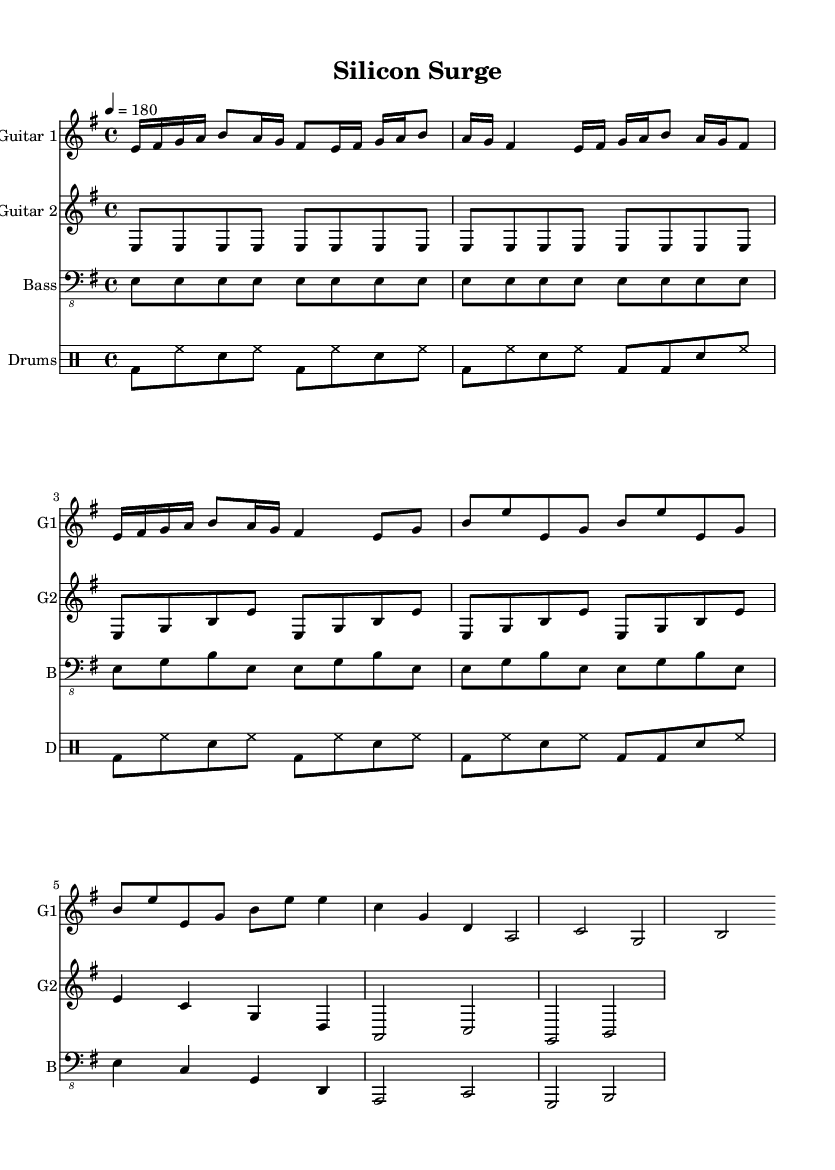What is the key signature of this music? The key signature shown in the music is E minor, which has one sharp (F#). This can be determined by looking at the key signature indicated at the beginning of the staff lines.
Answer: E minor What is the time signature of this music? The time signature is 4/4, which indicates four beats in each measure and a quarter note receives one beat. This can be seen at the beginning of the musical notation.
Answer: 4/4 What is the tempo marking for this piece? The tempo marking is 180 beats per minute. It is indicated at the beginning of the score after the time signature, specifying the speed of the piece.
Answer: 180 How many measures are in the main riff? The main riff consists of 4 measures as it repeats the initial 2-measure riff twice. This can be calculated by counting the measures dedicated to that section of the music.
Answer: 4 What is the structure of the song based on the sections provided? The structure follows a pattern of Main Riff, Verse, Chorus, and Bridge, which is a typical arrangement found in thrash metal songs. Analyzing the different sections helps to understand this organization.
Answer: Main Riff, Verse, Chorus, Bridge What type of guitar is used for the first staff? The first staff indicates "Guitar 1" as the instrument name. This is shown explicitly in the header of that staff section, denoting the specific instrument being scored.
Answer: Guitar 1 What is the primary role of the bass in this piece? The bass primarily provides the foundational rhythm and reinforces the harmony within the song, which can be inferred from its corresponding notes and rhythmic patterns that align with the other instruments.
Answer: Harmonic foundation 